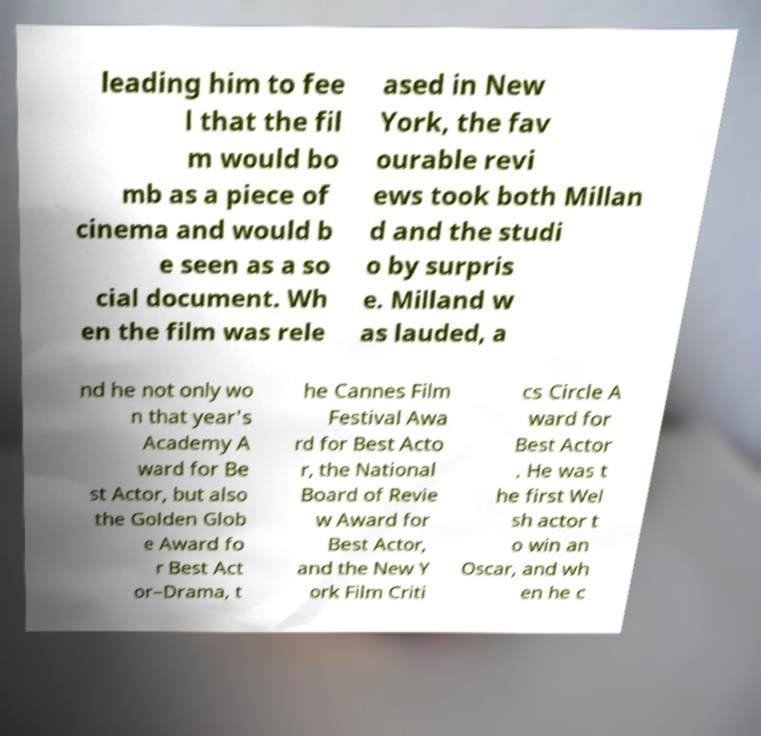There's text embedded in this image that I need extracted. Can you transcribe it verbatim? leading him to fee l that the fil m would bo mb as a piece of cinema and would b e seen as a so cial document. Wh en the film was rele ased in New York, the fav ourable revi ews took both Millan d and the studi o by surpris e. Milland w as lauded, a nd he not only wo n that year's Academy A ward for Be st Actor, but also the Golden Glob e Award fo r Best Act or–Drama, t he Cannes Film Festival Awa rd for Best Acto r, the National Board of Revie w Award for Best Actor, and the New Y ork Film Criti cs Circle A ward for Best Actor . He was t he first Wel sh actor t o win an Oscar, and wh en he c 